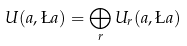Convert formula to latex. <formula><loc_0><loc_0><loc_500><loc_500>U ( a , \L a ) = \bigoplus _ { r } U _ { r } ( a , \L a )</formula> 